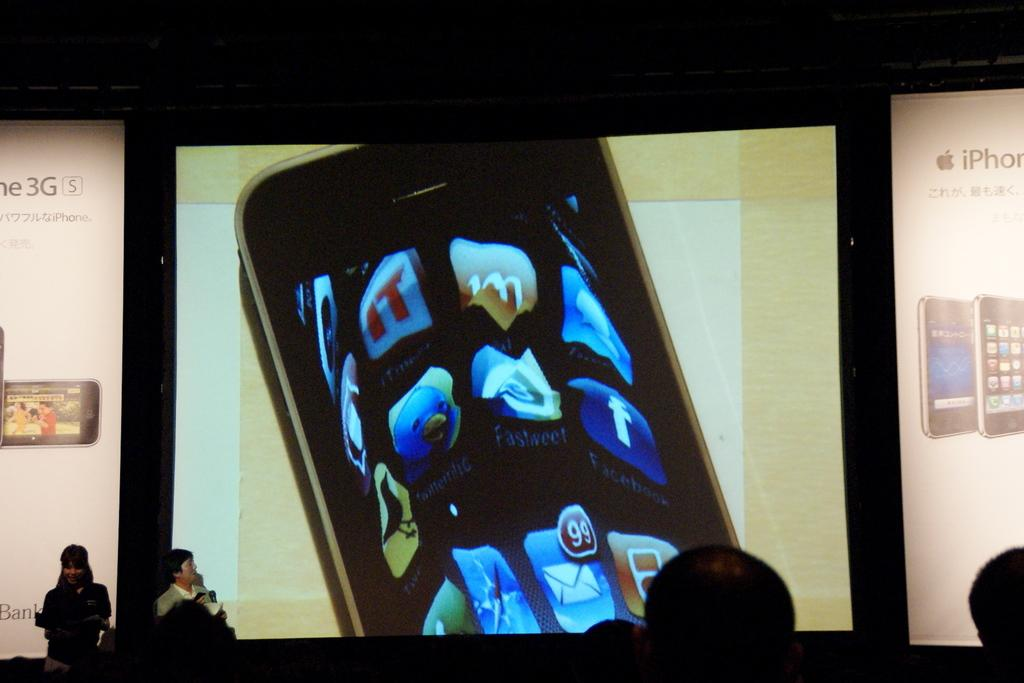How many people are present in the image? There are many people in the image. What can be seen in the background of the image? There is a screen with an image of a phone in the background. What type of haircut is the person in the hospital receiving in the image? There is no person receiving a haircut or any indication of a hospital in the image. 